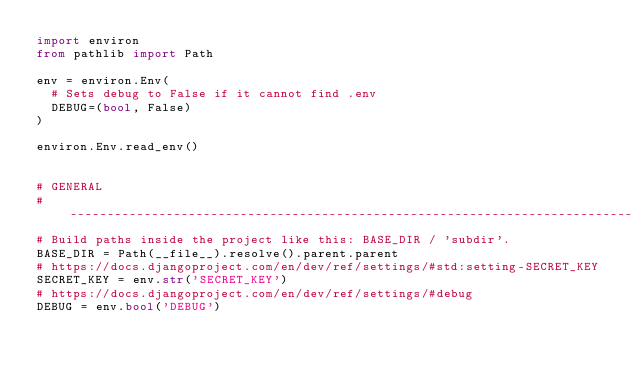<code> <loc_0><loc_0><loc_500><loc_500><_Python_>import environ
from pathlib import Path

env = environ.Env(
  # Sets debug to False if it cannot find .env
  DEBUG=(bool, False)
)

environ.Env.read_env()


# GENERAL
# ------------------------------------------------------------------------------
# Build paths inside the project like this: BASE_DIR / 'subdir'.
BASE_DIR = Path(__file__).resolve().parent.parent
# https://docs.djangoproject.com/en/dev/ref/settings/#std:setting-SECRET_KEY
SECRET_KEY = env.str('SECRET_KEY')
# https://docs.djangoproject.com/en/dev/ref/settings/#debug
DEBUG = env.bool('DEBUG')</code> 